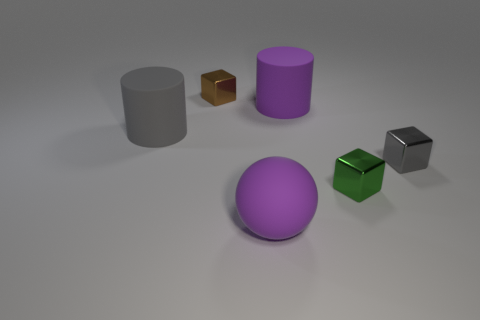The large rubber thing that is in front of the gray thing right of the sphere is what shape?
Offer a very short reply. Sphere. There is a gray object that is the same size as the purple cylinder; what is its shape?
Offer a terse response. Cylinder. Is there another shiny thing of the same shape as the tiny brown shiny thing?
Your answer should be very brief. Yes. What material is the tiny gray block?
Your answer should be compact. Metal. Are there any small cubes in front of the large matte ball?
Keep it short and to the point. No. How many tiny green metal blocks are right of the purple thing that is behind the ball?
Your answer should be compact. 1. What material is the green block that is the same size as the brown object?
Offer a very short reply. Metal. What number of other objects are there of the same material as the purple sphere?
Give a very brief answer. 2. What number of metallic objects are behind the gray metal object?
Keep it short and to the point. 1. How many cylinders are either shiny things or green objects?
Offer a very short reply. 0. 